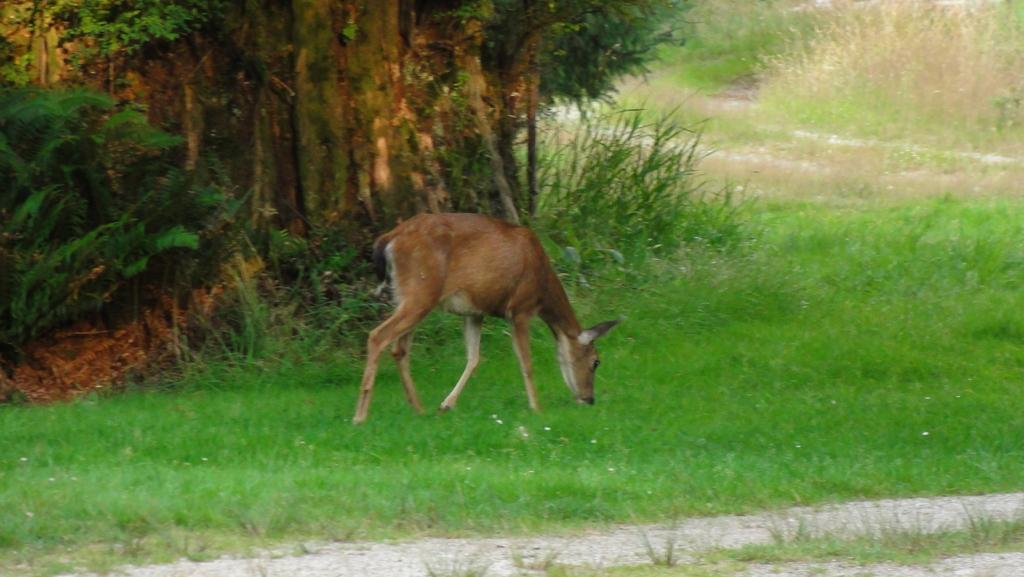What animal can be seen in the image? There is a deer in the image. What is the deer doing in the image? The deer is grazing grass. What can be seen in the background of the image? There are trees, grass, and plants visible in the background of the image. What type of destruction can be seen happening to the stage in the image? There is no stage present in the image, and therefore no destruction can be observed. What type of slip can be seen on the deer's hooves in the image? There is no slip visible on the deer's hooves in the image. 